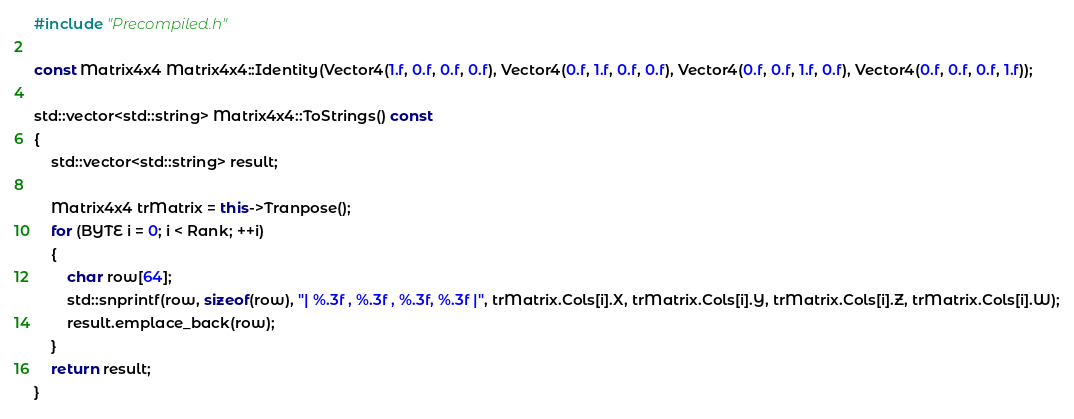<code> <loc_0><loc_0><loc_500><loc_500><_C++_>
#include "Precompiled.h"

const Matrix4x4 Matrix4x4::Identity(Vector4(1.f, 0.f, 0.f, 0.f), Vector4(0.f, 1.f, 0.f, 0.f), Vector4(0.f, 0.f, 1.f, 0.f), Vector4(0.f, 0.f, 0.f, 1.f));

std::vector<std::string> Matrix4x4::ToStrings() const
{
	std::vector<std::string> result;

	Matrix4x4 trMatrix = this->Tranpose();
	for (BYTE i = 0; i < Rank; ++i)
	{
		char row[64];
		std::snprintf(row, sizeof(row), "| %.3f , %.3f , %.3f, %.3f |", trMatrix.Cols[i].X, trMatrix.Cols[i].Y, trMatrix.Cols[i].Z, trMatrix.Cols[i].W);
		result.emplace_back(row);
	}
	return result;
}
</code> 